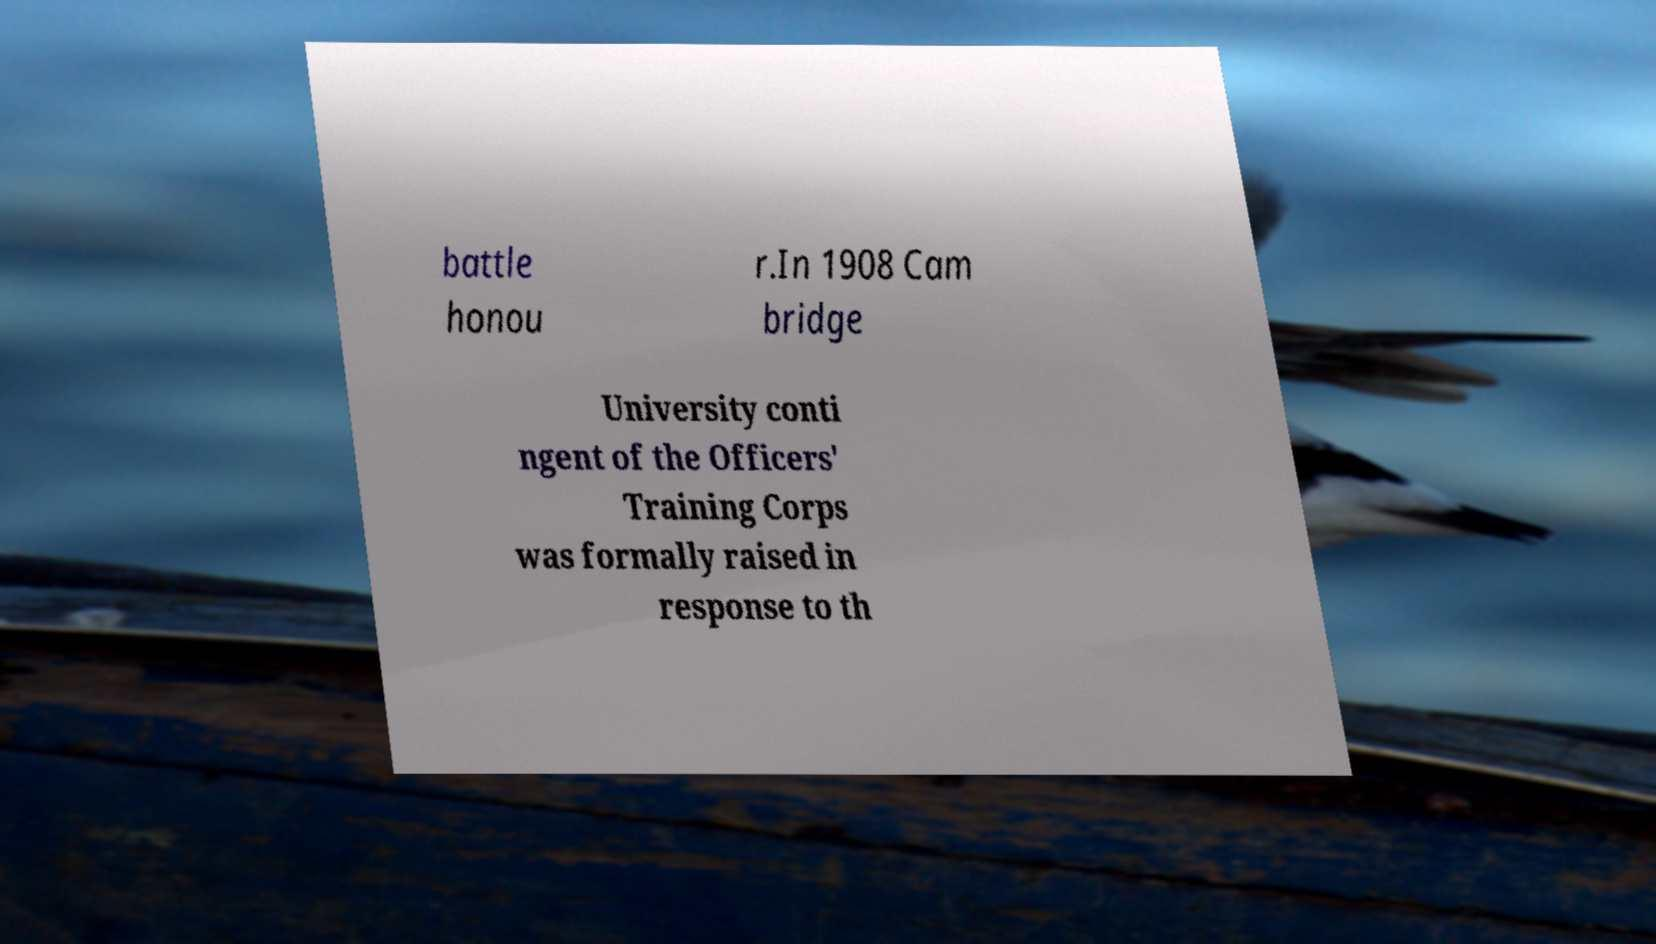Can you read and provide the text displayed in the image?This photo seems to have some interesting text. Can you extract and type it out for me? battle honou r.In 1908 Cam bridge University conti ngent of the Officers' Training Corps was formally raised in response to th 